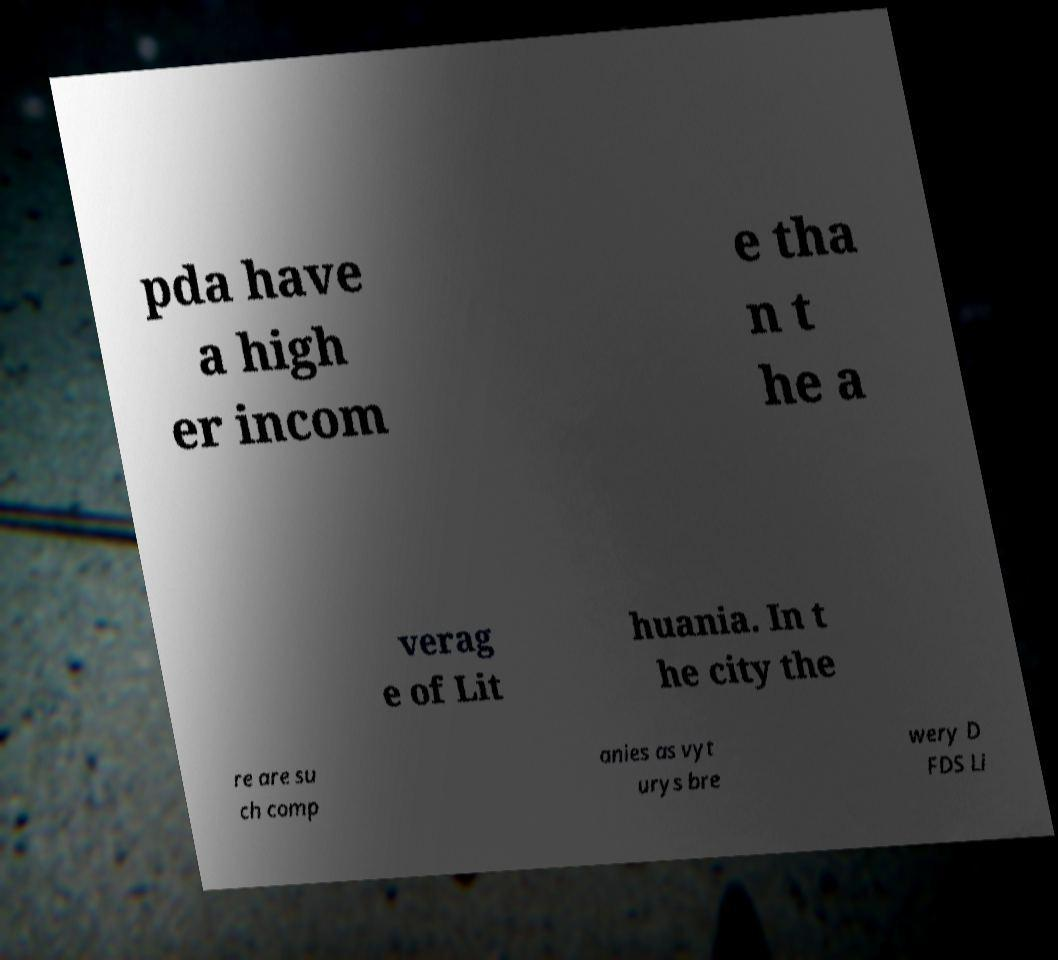Please read and relay the text visible in this image. What does it say? pda have a high er incom e tha n t he a verag e of Lit huania. In t he city the re are su ch comp anies as vyt urys bre wery D FDS Li 